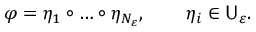<formula> <loc_0><loc_0><loc_500><loc_500>\varphi = \eta _ { 1 } \circ \dots \circ \eta _ { N _ { \varepsilon } } , \quad \eta _ { i } \in U _ { \varepsilon } .</formula> 